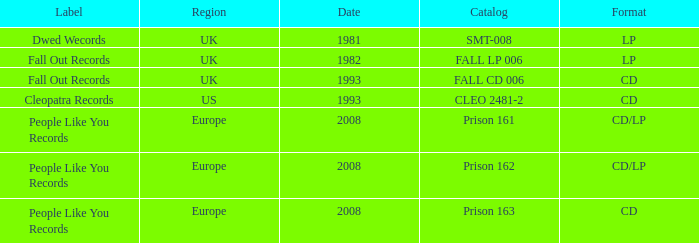Which Label has a Date smaller than 2008, and a Catalog of fall cd 006? Fall Out Records. 